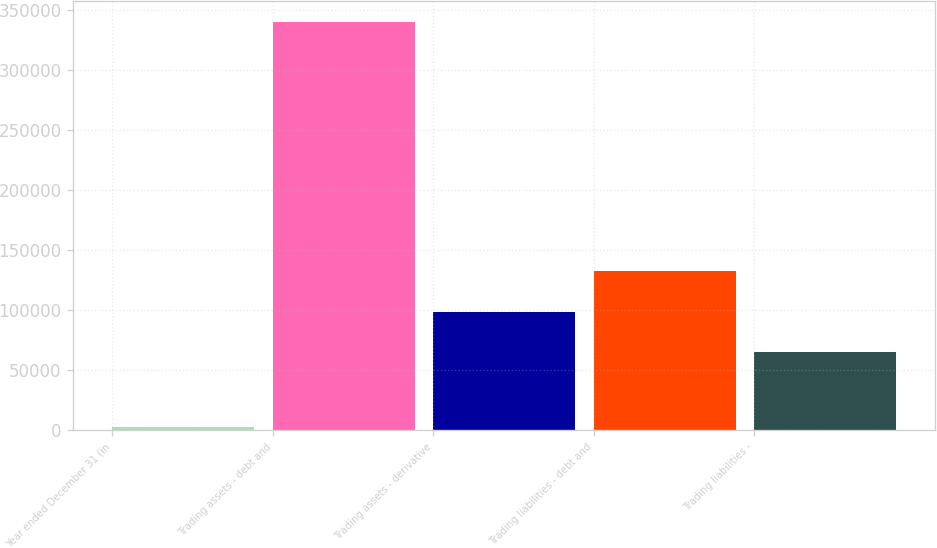<chart> <loc_0><loc_0><loc_500><loc_500><bar_chart><fcel>Year ended December 31 (in<fcel>Trading assets - debt and<fcel>Trading assets - derivative<fcel>Trading liabilities - debt and<fcel>Trading liabilities -<nl><fcel>2013<fcel>340449<fcel>98396.6<fcel>132240<fcel>64553<nl></chart> 